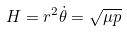Convert formula to latex. <formula><loc_0><loc_0><loc_500><loc_500>H = r ^ { 2 } \dot { \theta } = \sqrt { \mu p }</formula> 